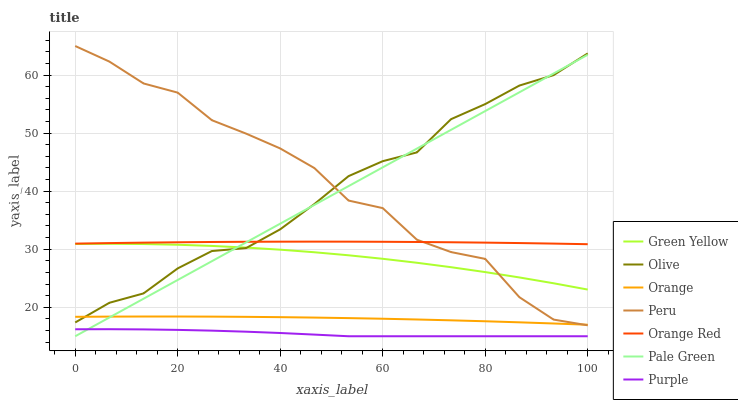Does Purple have the minimum area under the curve?
Answer yes or no. Yes. Does Peru have the maximum area under the curve?
Answer yes or no. Yes. Does Orange have the minimum area under the curve?
Answer yes or no. No. Does Orange have the maximum area under the curve?
Answer yes or no. No. Is Pale Green the smoothest?
Answer yes or no. Yes. Is Peru the roughest?
Answer yes or no. Yes. Is Orange the smoothest?
Answer yes or no. No. Is Orange the roughest?
Answer yes or no. No. Does Orange have the lowest value?
Answer yes or no. No. Does Orange have the highest value?
Answer yes or no. No. Is Orange less than Orange Red?
Answer yes or no. Yes. Is Olive greater than Purple?
Answer yes or no. Yes. Does Orange intersect Orange Red?
Answer yes or no. No. 